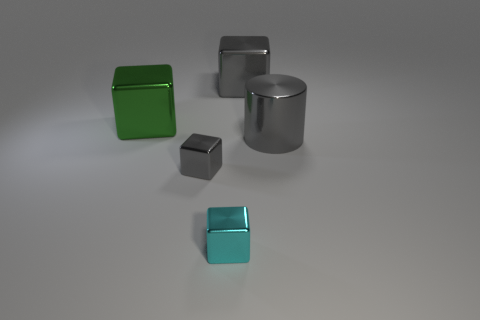There is a object behind the green metal object; does it have the same color as the big thing in front of the big green cube?
Your answer should be very brief. Yes. What number of other things are the same size as the green thing?
Your answer should be compact. 2. There is a large metal cylinder behind the small shiny thing to the left of the cyan metal block; is there a block that is behind it?
Give a very brief answer. Yes. The other small thing that is the same shape as the cyan metallic object is what color?
Your response must be concise. Gray. Are there the same number of gray metal objects behind the cyan metal block and gray cylinders?
Keep it short and to the point. No. There is a small cyan metallic object; are there any shiny objects right of it?
Give a very brief answer. Yes. There is a gray cube in front of the large gray thing that is on the right side of the big cube that is right of the cyan shiny thing; what is its size?
Offer a terse response. Small. Does the gray object behind the large cylinder have the same shape as the gray metallic object that is in front of the gray cylinder?
Your response must be concise. Yes. There is a green thing that is the same shape as the cyan shiny thing; what size is it?
Provide a succinct answer. Large. How many gray cylinders are made of the same material as the green block?
Offer a terse response. 1. 